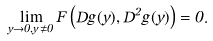<formula> <loc_0><loc_0><loc_500><loc_500>\lim _ { y \to 0 , y \neq 0 } F \left ( D g ( y ) , D ^ { 2 } g ( y ) \right ) = 0 .</formula> 